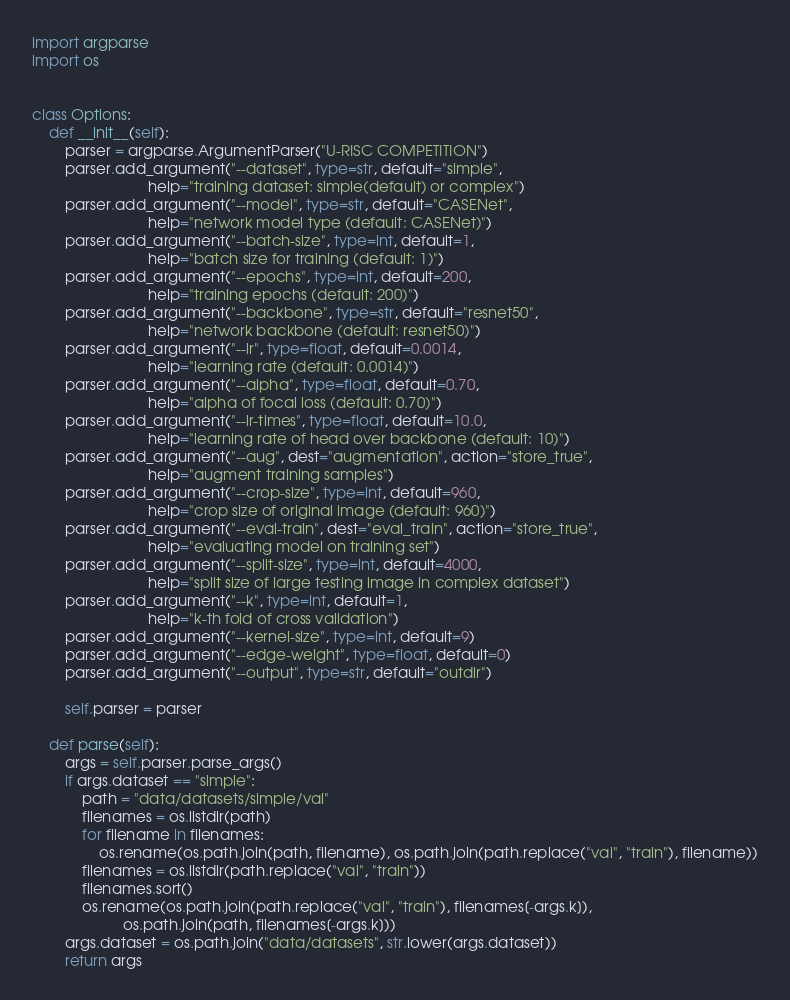Convert code to text. <code><loc_0><loc_0><loc_500><loc_500><_Python_>import argparse
import os


class Options:
    def __init__(self):
        parser = argparse.ArgumentParser("U-RISC COMPETITION")
        parser.add_argument("--dataset", type=str, default="simple",
                            help="training dataset: simple(default) or complex")
        parser.add_argument("--model", type=str, default="CASENet",
                            help="network model type (default: CASENet)")
        parser.add_argument("--batch-size", type=int, default=1,
                            help="batch size for training (default: 1)")
        parser.add_argument("--epochs", type=int, default=200,
                            help="training epochs (default: 200)")
        parser.add_argument("--backbone", type=str, default="resnet50",
                            help="network backbone (default: resnet50)")
        parser.add_argument("--lr", type=float, default=0.0014,
                            help="learning rate (default: 0.0014)")
        parser.add_argument("--alpha", type=float, default=0.70,
                            help="alpha of focal loss (default: 0.70)")
        parser.add_argument("--lr-times", type=float, default=10.0,
                            help="learning rate of head over backbone (default: 10)")
        parser.add_argument("--aug", dest="augmentation", action="store_true",
                            help="augment training samples")
        parser.add_argument("--crop-size", type=int, default=960,
                            help="crop size of original image (default: 960)")
        parser.add_argument("--eval-train", dest="eval_train", action="store_true",
                            help="evaluating model on training set")
        parser.add_argument("--split-size", type=int, default=4000,
                            help="split size of large testing image in complex dataset")
        parser.add_argument("--k", type=int, default=1,
                            help="k-th fold of cross validation")
        parser.add_argument("--kernel-size", type=int, default=9)
        parser.add_argument("--edge-weight", type=float, default=0)
        parser.add_argument("--output", type=str, default="outdir")

        self.parser = parser

    def parse(self):
        args = self.parser.parse_args()
        if args.dataset == "simple":
            path = "data/datasets/simple/val"
            filenames = os.listdir(path)
            for filename in filenames:
                os.rename(os.path.join(path, filename), os.path.join(path.replace("val", "train"), filename))
            filenames = os.listdir(path.replace("val", "train"))
            filenames.sort()
            os.rename(os.path.join(path.replace("val", "train"), filenames[-args.k]),
                      os.path.join(path, filenames[-args.k]))
        args.dataset = os.path.join("data/datasets", str.lower(args.dataset))
        return args
</code> 